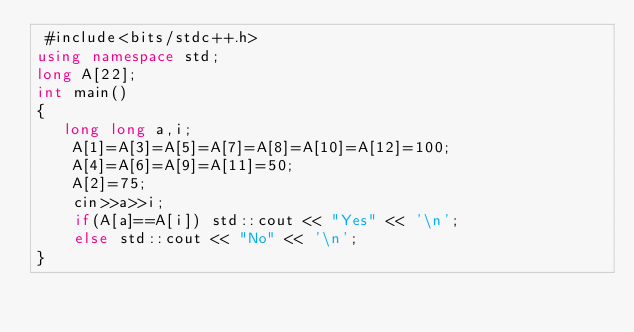<code> <loc_0><loc_0><loc_500><loc_500><_C++_> #include<bits/stdc++.h>
using namespace std;
long A[22];
int main()
{
   long long a,i;
    A[1]=A[3]=A[5]=A[7]=A[8]=A[10]=A[12]=100;
    A[4]=A[6]=A[9]=A[11]=50;
    A[2]=75;
    cin>>a>>i;
    if(A[a]==A[i]) std::cout << "Yes" << '\n';
    else std::cout << "No" << '\n';
}
</code> 